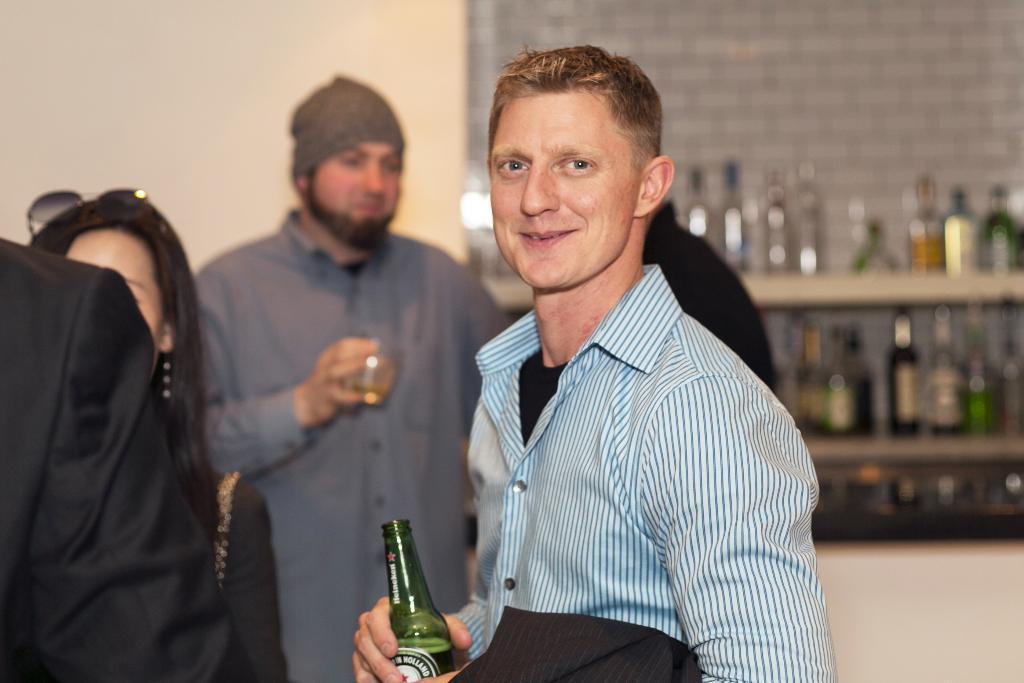Describe this image in one or two sentences. In this image we can see some people are standing near to the wall, so many bottles in the self and some people are holding some objects. 